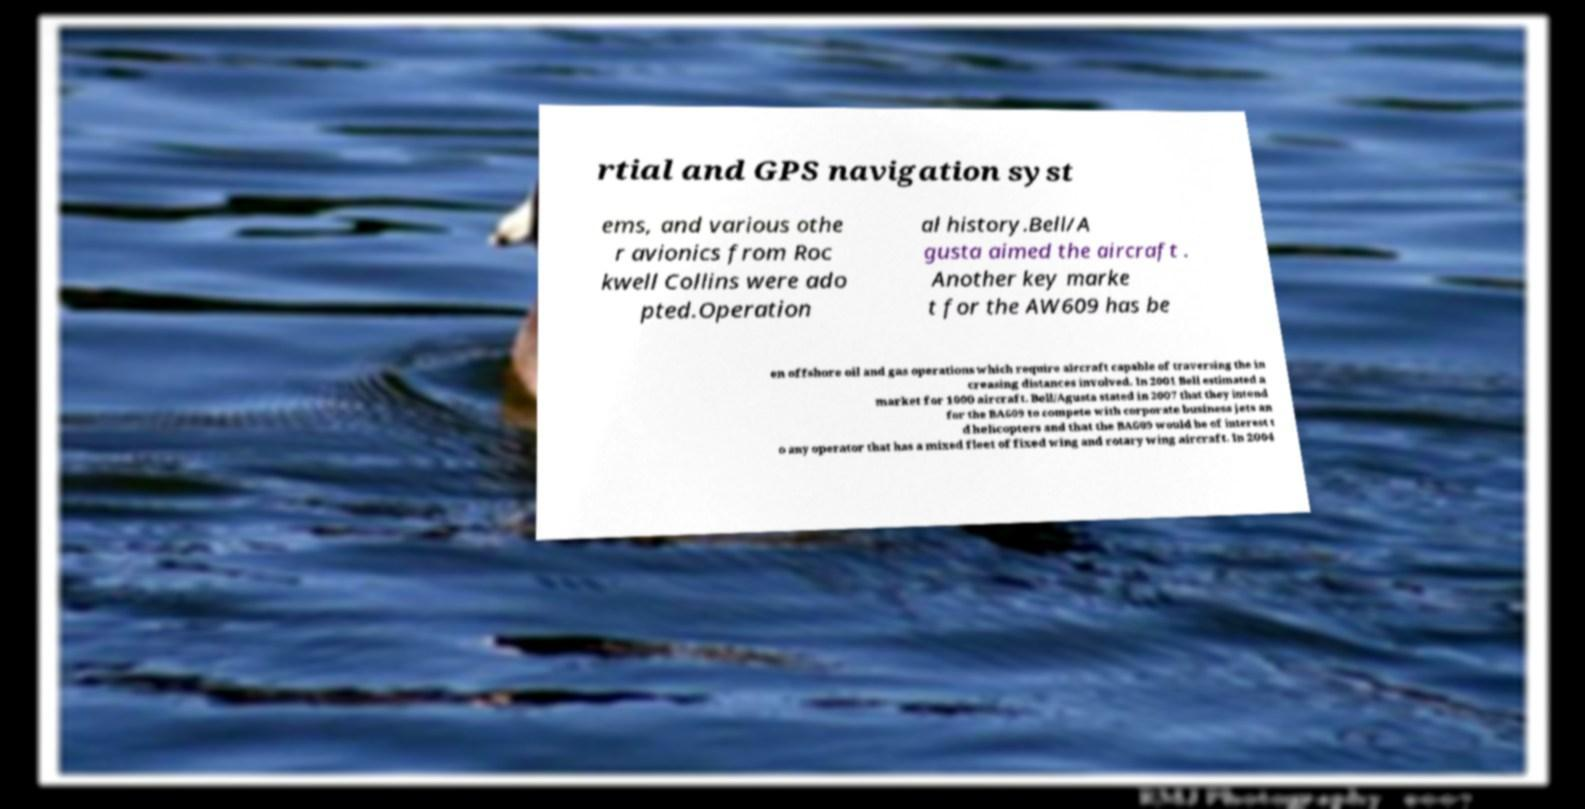Could you assist in decoding the text presented in this image and type it out clearly? rtial and GPS navigation syst ems, and various othe r avionics from Roc kwell Collins were ado pted.Operation al history.Bell/A gusta aimed the aircraft . Another key marke t for the AW609 has be en offshore oil and gas operations which require aircraft capable of traversing the in creasing distances involved. In 2001 Bell estimated a market for 1000 aircraft. Bell/Agusta stated in 2007 that they intend for the BA609 to compete with corporate business jets an d helicopters and that the BA609 would be of interest t o any operator that has a mixed fleet of fixed wing and rotary wing aircraft. In 2004 